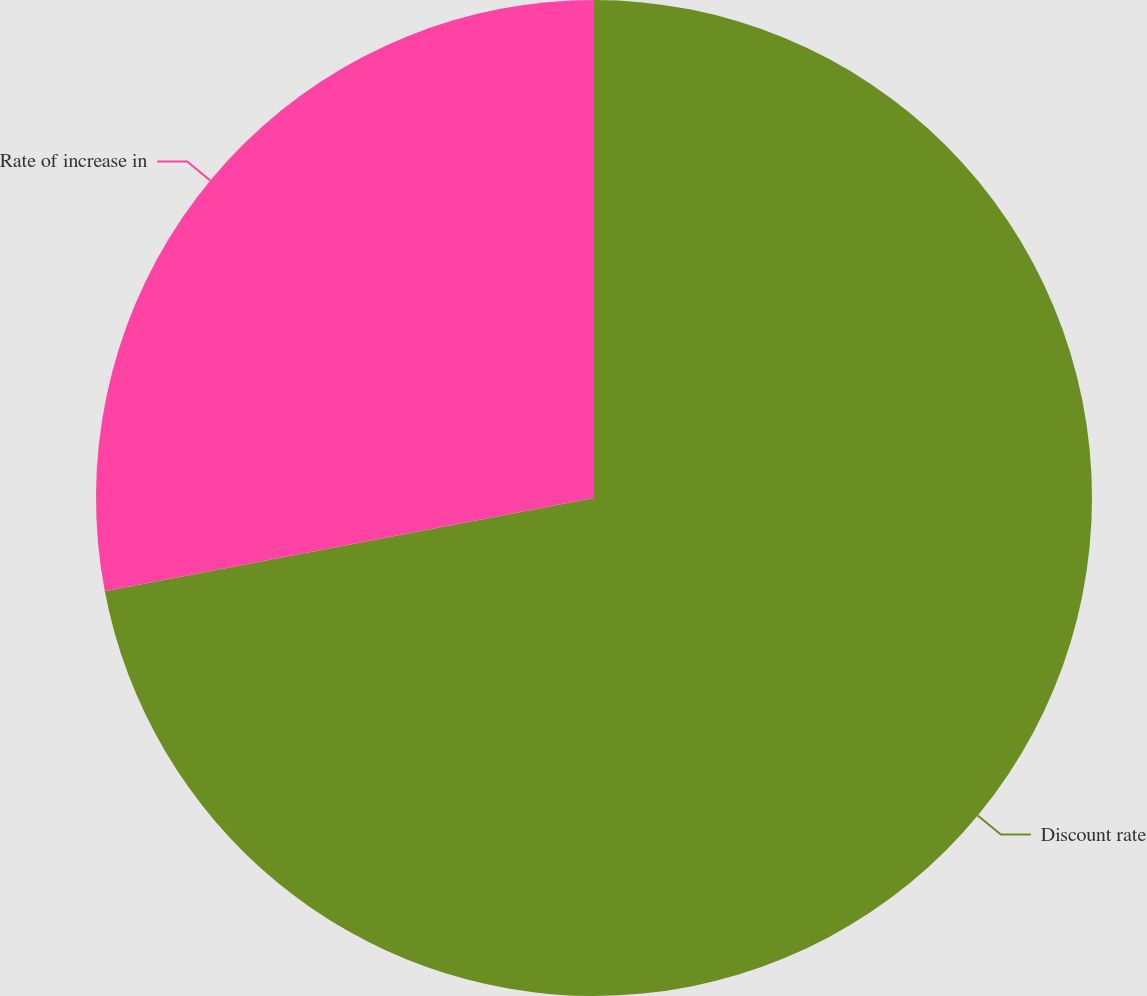<chart> <loc_0><loc_0><loc_500><loc_500><pie_chart><fcel>Discount rate<fcel>Rate of increase in<nl><fcel>72.0%<fcel>28.0%<nl></chart> 